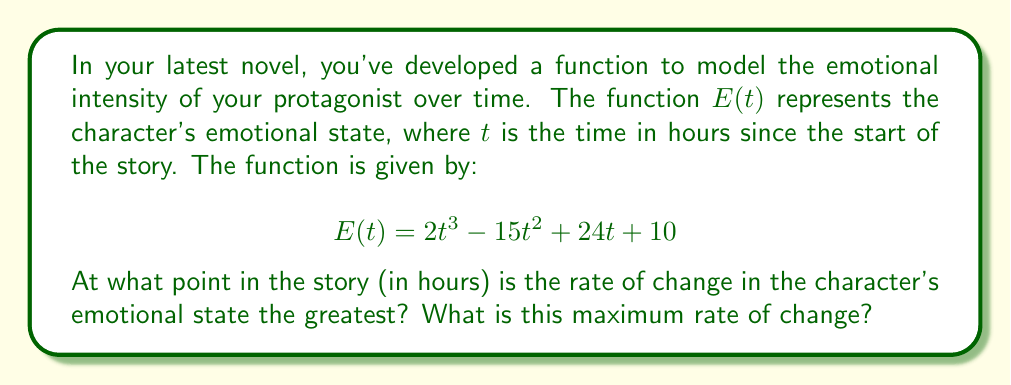Can you answer this question? To solve this problem, we need to follow these steps:

1) The rate of change of the character's emotional state is represented by the derivative of $E(t)$. Let's call this $E'(t)$.

2) Find $E'(t)$ by differentiating $E(t)$:
   $$E'(t) = 6t^2 - 30t + 24$$

3) To find the maximum rate of change, we need to find where the derivative of $E'(t)$ equals zero. Let's call this second derivative $E''(t)$.

4) Find $E''(t)$:
   $$E''(t) = 12t - 30$$

5) Set $E''(t) = 0$ and solve for $t$:
   $$12t - 30 = 0$$
   $$12t = 30$$
   $$t = \frac{30}{12} = 2.5$$

6) To confirm this is a maximum (not a minimum), check that $E'''(t) < 0$:
   $$E'''(t) = 12$$
   Since this is positive, the point we found is actually a minimum of $E'(t)$, meaning it's an inflection point of $E(t)$.

7) The maximum rate of change must therefore occur at one of the endpoints of the domain. Assuming the story takes place over a 24-hour period, we should evaluate $E'(0)$ and $E'(24)$:

   $E'(0) = 24$
   $E'(24) = 6(24)^2 - 30(24) + 24 = 3456 - 720 + 24 = 2760$

8) The larger of these is $E'(24) = 2760$, so this is our maximum rate of change.
Answer: The rate of change in the character's emotional state is greatest at 24 hours into the story, with a maximum rate of change of 2760 emotional units per hour. 